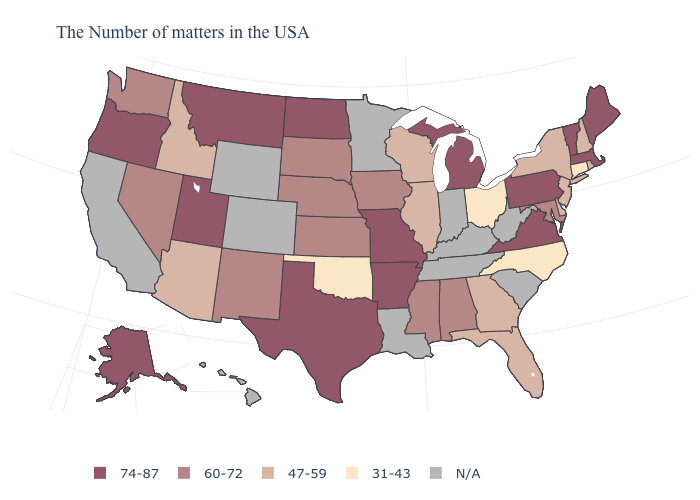How many symbols are there in the legend?
Write a very short answer. 5. What is the value of Oregon?
Be succinct. 74-87. Does the first symbol in the legend represent the smallest category?
Concise answer only. No. Among the states that border Washington , which have the highest value?
Answer briefly. Oregon. What is the value of Nevada?
Be succinct. 60-72. Among the states that border Massachusetts , which have the lowest value?
Quick response, please. Connecticut. Does the map have missing data?
Give a very brief answer. Yes. Which states have the lowest value in the West?
Give a very brief answer. Arizona, Idaho. What is the highest value in the USA?
Write a very short answer. 74-87. What is the highest value in the South ?
Quick response, please. 74-87. Does Iowa have the lowest value in the USA?
Answer briefly. No. What is the lowest value in the USA?
Keep it brief. 31-43. Among the states that border Tennessee , does North Carolina have the highest value?
Keep it brief. No. Name the states that have a value in the range 74-87?
Answer briefly. Maine, Massachusetts, Vermont, Pennsylvania, Virginia, Michigan, Missouri, Arkansas, Texas, North Dakota, Utah, Montana, Oregon, Alaska. Name the states that have a value in the range 74-87?
Answer briefly. Maine, Massachusetts, Vermont, Pennsylvania, Virginia, Michigan, Missouri, Arkansas, Texas, North Dakota, Utah, Montana, Oregon, Alaska. 